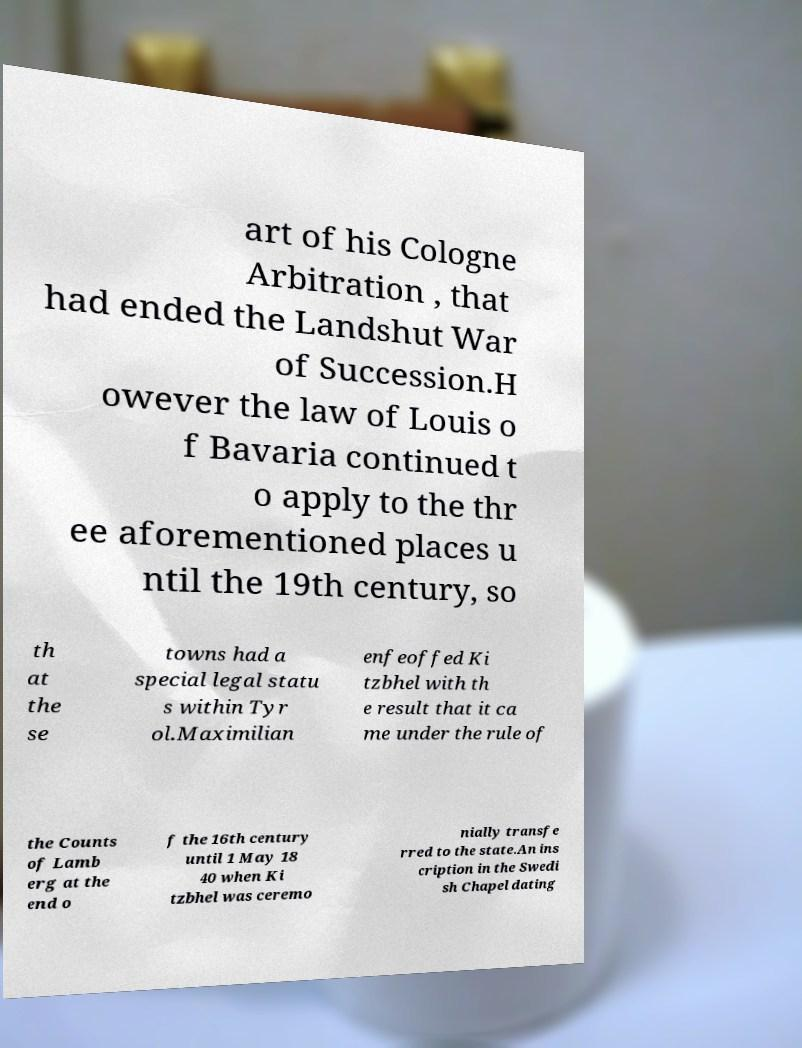Can you accurately transcribe the text from the provided image for me? art of his Cologne Arbitration , that had ended the Landshut War of Succession.H owever the law of Louis o f Bavaria continued t o apply to the thr ee aforementioned places u ntil the 19th century, so th at the se towns had a special legal statu s within Tyr ol.Maximilian enfeoffed Ki tzbhel with th e result that it ca me under the rule of the Counts of Lamb erg at the end o f the 16th century until 1 May 18 40 when Ki tzbhel was ceremo nially transfe rred to the state.An ins cription in the Swedi sh Chapel dating 